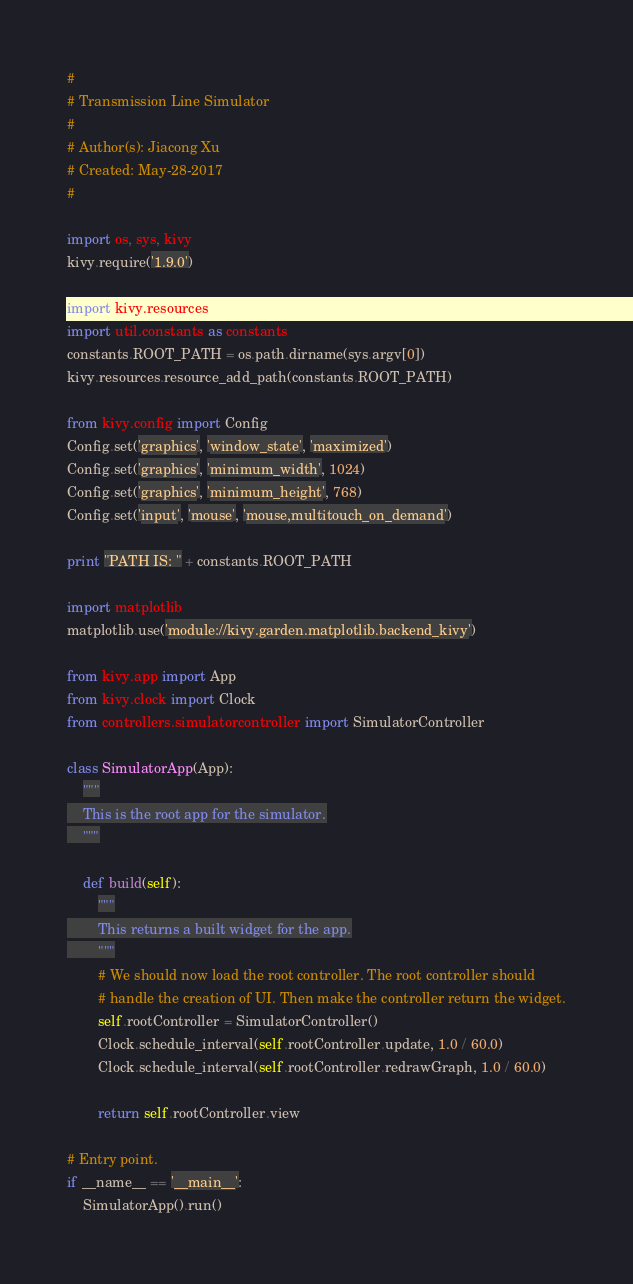<code> <loc_0><loc_0><loc_500><loc_500><_Python_>#
# Transmission Line Simulator
# 
# Author(s): Jiacong Xu
# Created: May-28-2017
#

import os, sys, kivy
kivy.require('1.9.0')

import kivy.resources
import util.constants as constants
constants.ROOT_PATH = os.path.dirname(sys.argv[0])
kivy.resources.resource_add_path(constants.ROOT_PATH)

from kivy.config import Config
Config.set('graphics', 'window_state', 'maximized')
Config.set('graphics', 'minimum_width', 1024)
Config.set('graphics', 'minimum_height', 768)
Config.set('input', 'mouse', 'mouse,multitouch_on_demand')

print "PATH IS: " + constants.ROOT_PATH

import matplotlib
matplotlib.use('module://kivy.garden.matplotlib.backend_kivy')

from kivy.app import App
from kivy.clock import Clock
from controllers.simulatorcontroller import SimulatorController

class SimulatorApp(App):
    """
    This is the root app for the simulator.
    """

    def build(self):
        """
        This returns a built widget for the app.
        """
        # We should now load the root controller. The root controller should
        # handle the creation of UI. Then make the controller return the widget.
        self.rootController = SimulatorController()
        Clock.schedule_interval(self.rootController.update, 1.0 / 60.0)
        Clock.schedule_interval(self.rootController.redrawGraph, 1.0 / 60.0)
        
        return self.rootController.view

# Entry point.
if __name__ == '__main__':
    SimulatorApp().run()
</code> 